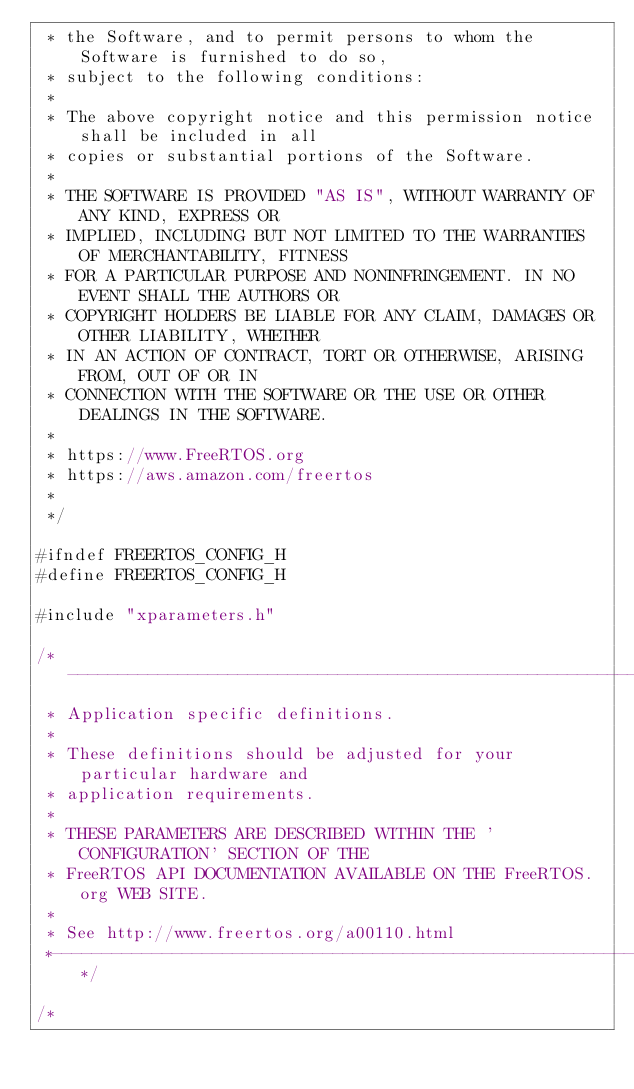<code> <loc_0><loc_0><loc_500><loc_500><_C_> * the Software, and to permit persons to whom the Software is furnished to do so,
 * subject to the following conditions:
 *
 * The above copyright notice and this permission notice shall be included in all
 * copies or substantial portions of the Software.
 *
 * THE SOFTWARE IS PROVIDED "AS IS", WITHOUT WARRANTY OF ANY KIND, EXPRESS OR
 * IMPLIED, INCLUDING BUT NOT LIMITED TO THE WARRANTIES OF MERCHANTABILITY, FITNESS
 * FOR A PARTICULAR PURPOSE AND NONINFRINGEMENT. IN NO EVENT SHALL THE AUTHORS OR
 * COPYRIGHT HOLDERS BE LIABLE FOR ANY CLAIM, DAMAGES OR OTHER LIABILITY, WHETHER
 * IN AN ACTION OF CONTRACT, TORT OR OTHERWISE, ARISING FROM, OUT OF OR IN
 * CONNECTION WITH THE SOFTWARE OR THE USE OR OTHER DEALINGS IN THE SOFTWARE.
 *
 * https://www.FreeRTOS.org
 * https://aws.amazon.com/freertos
 *
 */

#ifndef FREERTOS_CONFIG_H
#define FREERTOS_CONFIG_H

#include "xparameters.h"

/*-----------------------------------------------------------
 * Application specific definitions.
 *
 * These definitions should be adjusted for your particular hardware and
 * application requirements.
 *
 * THESE PARAMETERS ARE DESCRIBED WITHIN THE 'CONFIGURATION' SECTION OF THE
 * FreeRTOS API DOCUMENTATION AVAILABLE ON THE FreeRTOS.org WEB SITE.
 *
 * See http://www.freertos.org/a00110.html
 *----------------------------------------------------------*/

/*</code> 